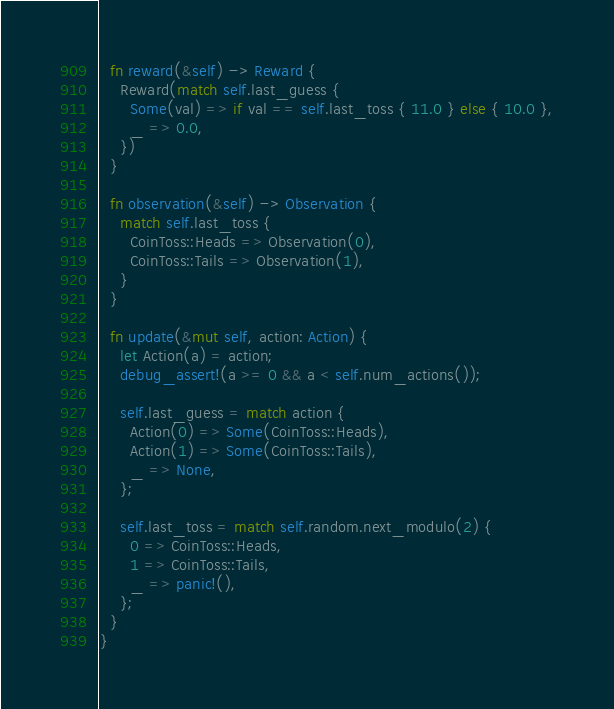<code> <loc_0><loc_0><loc_500><loc_500><_Rust_>  fn reward(&self) -> Reward {
    Reward(match self.last_guess {
      Some(val) => if val == self.last_toss { 11.0 } else { 10.0 },
      _ => 0.0,
    })
  }

  fn observation(&self) -> Observation {
    match self.last_toss {
      CoinToss::Heads => Observation(0),
      CoinToss::Tails => Observation(1),
    }
  }

  fn update(&mut self, action: Action) {
    let Action(a) = action;
    debug_assert!(a >= 0 && a < self.num_actions());

    self.last_guess = match action {
      Action(0) => Some(CoinToss::Heads),
      Action(1) => Some(CoinToss::Tails),
      _ => None,
    };

    self.last_toss = match self.random.next_modulo(2) {
      0 => CoinToss::Heads,
      1 => CoinToss::Tails,
      _ => panic!(),
    };
  }
}
</code> 